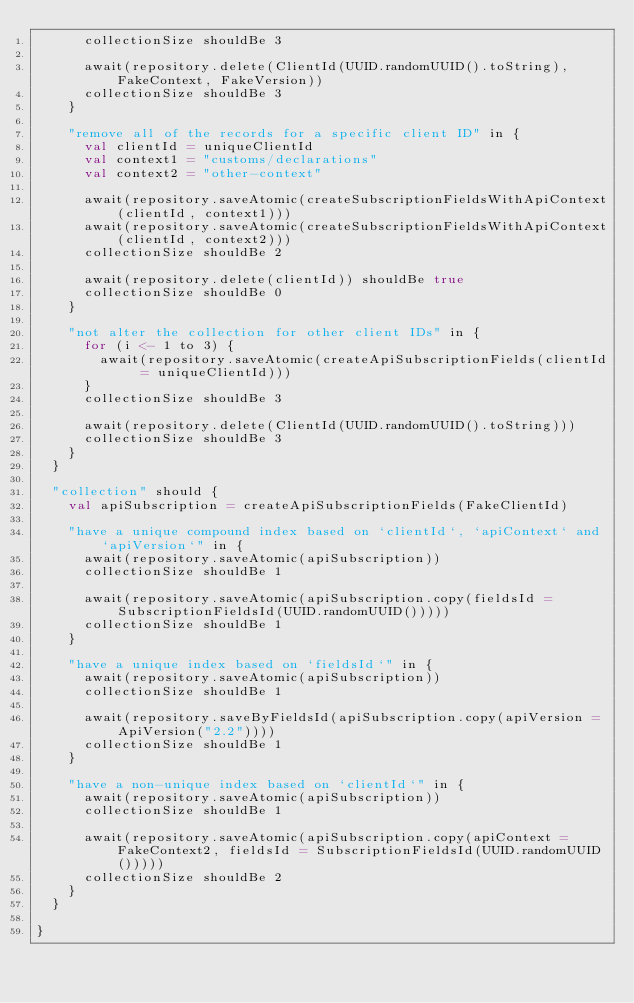Convert code to text. <code><loc_0><loc_0><loc_500><loc_500><_Scala_>      collectionSize shouldBe 3

      await(repository.delete(ClientId(UUID.randomUUID().toString), FakeContext, FakeVersion))
      collectionSize shouldBe 3
    }

    "remove all of the records for a specific client ID" in {
      val clientId = uniqueClientId
      val context1 = "customs/declarations"
      val context2 = "other-context"

      await(repository.saveAtomic(createSubscriptionFieldsWithApiContext(clientId, context1)))
      await(repository.saveAtomic(createSubscriptionFieldsWithApiContext(clientId, context2)))
      collectionSize shouldBe 2

      await(repository.delete(clientId)) shouldBe true
      collectionSize shouldBe 0
    }

    "not alter the collection for other client IDs" in {
      for (i <- 1 to 3) {
        await(repository.saveAtomic(createApiSubscriptionFields(clientId = uniqueClientId)))
      }
      collectionSize shouldBe 3

      await(repository.delete(ClientId(UUID.randomUUID().toString)))
      collectionSize shouldBe 3
    }
  }

  "collection" should {
    val apiSubscription = createApiSubscriptionFields(FakeClientId)

    "have a unique compound index based on `clientId`, `apiContext` and `apiVersion`" in {
      await(repository.saveAtomic(apiSubscription))
      collectionSize shouldBe 1

      await(repository.saveAtomic(apiSubscription.copy(fieldsId = SubscriptionFieldsId(UUID.randomUUID()))))
      collectionSize shouldBe 1
    }

    "have a unique index based on `fieldsId`" in {
      await(repository.saveAtomic(apiSubscription))
      collectionSize shouldBe 1

      await(repository.saveByFieldsId(apiSubscription.copy(apiVersion = ApiVersion("2.2"))))
      collectionSize shouldBe 1
    }

    "have a non-unique index based on `clientId`" in {
      await(repository.saveAtomic(apiSubscription))
      collectionSize shouldBe 1

      await(repository.saveAtomic(apiSubscription.copy(apiContext = FakeContext2, fieldsId = SubscriptionFieldsId(UUID.randomUUID()))))
      collectionSize shouldBe 2
    }
  }

}
</code> 